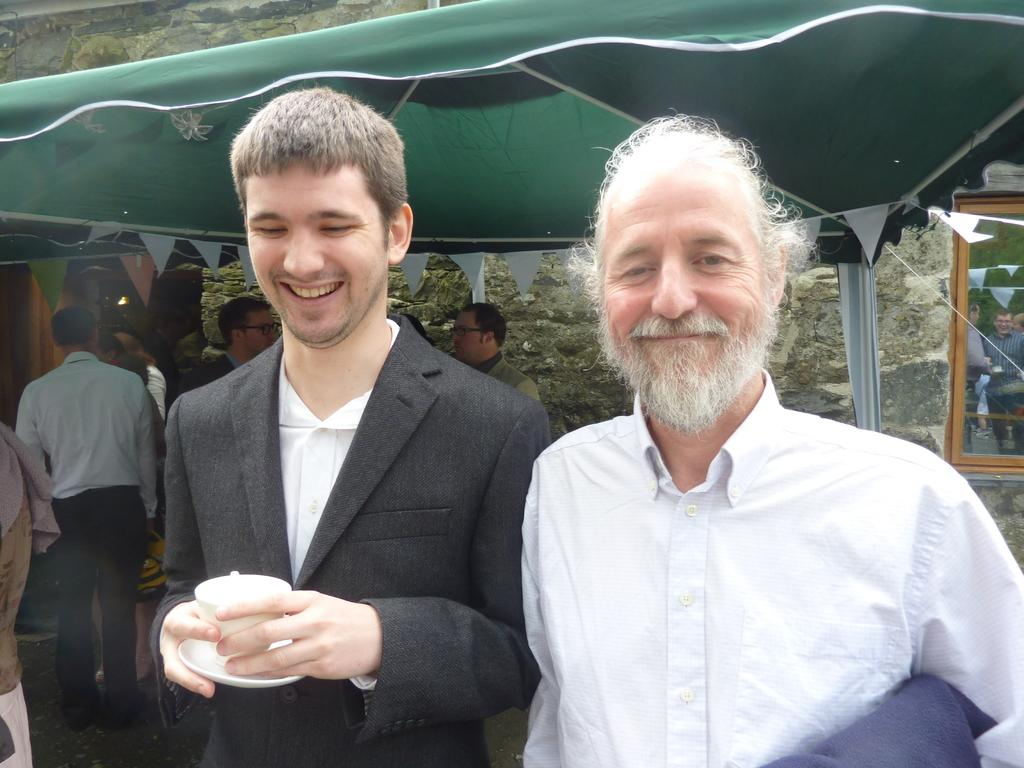How many people are in the image? There are people in the image, but the exact number is not specified. What is one person holding in the image? One person is holding a cup in the image. What type of shelter is visible in the image? There is a tent in the image. What architectural feature can be seen in the image? There is a window and a wall visible in the image. What type of boot is the friend wearing in the image? There is no mention of a friend or a boot in the image. The image only contains people, a cup, a tent, a window, and a wall. 